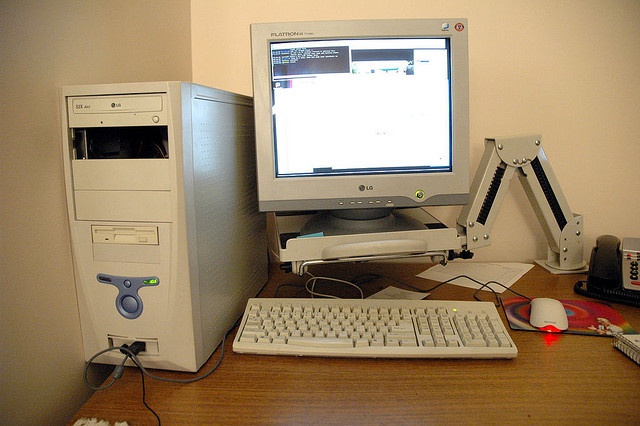Describe the objects in this image and their specific colors. I can see dining table in gray, maroon, olive, and tan tones, tv in gray, white, and tan tones, keyboard in gray and tan tones, mouse in gray, tan, and maroon tones, and book in gray, olive, and tan tones in this image. 